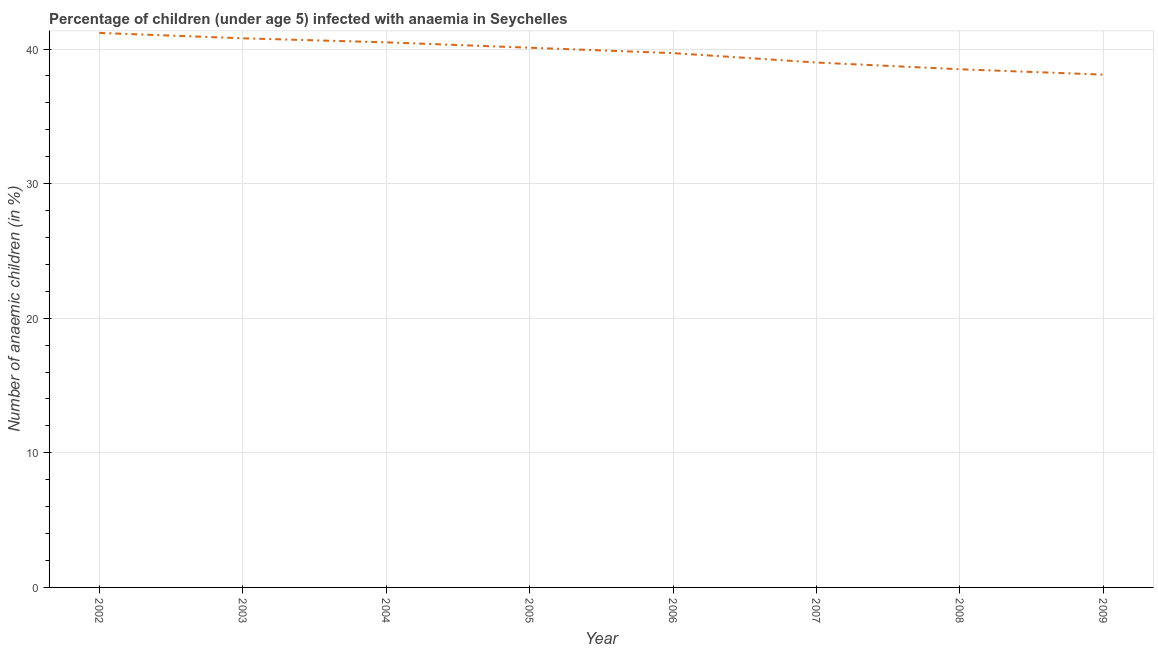What is the number of anaemic children in 2009?
Make the answer very short. 38.1. Across all years, what is the maximum number of anaemic children?
Your answer should be very brief. 41.2. Across all years, what is the minimum number of anaemic children?
Provide a succinct answer. 38.1. In which year was the number of anaemic children maximum?
Give a very brief answer. 2002. What is the sum of the number of anaemic children?
Your answer should be very brief. 317.9. What is the difference between the number of anaemic children in 2002 and 2007?
Keep it short and to the point. 2.2. What is the average number of anaemic children per year?
Your response must be concise. 39.74. What is the median number of anaemic children?
Keep it short and to the point. 39.9. In how many years, is the number of anaemic children greater than 34 %?
Provide a short and direct response. 8. What is the ratio of the number of anaemic children in 2005 to that in 2009?
Your answer should be compact. 1.05. Is the number of anaemic children in 2002 less than that in 2004?
Give a very brief answer. No. Is the difference between the number of anaemic children in 2004 and 2009 greater than the difference between any two years?
Provide a short and direct response. No. What is the difference between the highest and the second highest number of anaemic children?
Provide a short and direct response. 0.4. Is the sum of the number of anaemic children in 2002 and 2004 greater than the maximum number of anaemic children across all years?
Provide a succinct answer. Yes. What is the difference between the highest and the lowest number of anaemic children?
Give a very brief answer. 3.1. What is the difference between two consecutive major ticks on the Y-axis?
Provide a short and direct response. 10. Are the values on the major ticks of Y-axis written in scientific E-notation?
Your answer should be very brief. No. Does the graph contain grids?
Keep it short and to the point. Yes. What is the title of the graph?
Make the answer very short. Percentage of children (under age 5) infected with anaemia in Seychelles. What is the label or title of the X-axis?
Provide a short and direct response. Year. What is the label or title of the Y-axis?
Your response must be concise. Number of anaemic children (in %). What is the Number of anaemic children (in %) in 2002?
Keep it short and to the point. 41.2. What is the Number of anaemic children (in %) of 2003?
Give a very brief answer. 40.8. What is the Number of anaemic children (in %) of 2004?
Offer a very short reply. 40.5. What is the Number of anaemic children (in %) in 2005?
Your answer should be compact. 40.1. What is the Number of anaemic children (in %) in 2006?
Your response must be concise. 39.7. What is the Number of anaemic children (in %) of 2008?
Your answer should be compact. 38.5. What is the Number of anaemic children (in %) of 2009?
Your answer should be compact. 38.1. What is the difference between the Number of anaemic children (in %) in 2002 and 2004?
Offer a very short reply. 0.7. What is the difference between the Number of anaemic children (in %) in 2002 and 2005?
Give a very brief answer. 1.1. What is the difference between the Number of anaemic children (in %) in 2002 and 2007?
Keep it short and to the point. 2.2. What is the difference between the Number of anaemic children (in %) in 2002 and 2008?
Offer a terse response. 2.7. What is the difference between the Number of anaemic children (in %) in 2002 and 2009?
Provide a short and direct response. 3.1. What is the difference between the Number of anaemic children (in %) in 2003 and 2005?
Provide a succinct answer. 0.7. What is the difference between the Number of anaemic children (in %) in 2003 and 2007?
Your answer should be very brief. 1.8. What is the difference between the Number of anaemic children (in %) in 2004 and 2006?
Offer a terse response. 0.8. What is the difference between the Number of anaemic children (in %) in 2004 and 2007?
Offer a very short reply. 1.5. What is the difference between the Number of anaemic children (in %) in 2005 and 2007?
Ensure brevity in your answer.  1.1. What is the difference between the Number of anaemic children (in %) in 2005 and 2008?
Provide a short and direct response. 1.6. What is the difference between the Number of anaemic children (in %) in 2006 and 2009?
Offer a very short reply. 1.6. What is the difference between the Number of anaemic children (in %) in 2008 and 2009?
Make the answer very short. 0.4. What is the ratio of the Number of anaemic children (in %) in 2002 to that in 2003?
Provide a short and direct response. 1.01. What is the ratio of the Number of anaemic children (in %) in 2002 to that in 2006?
Your response must be concise. 1.04. What is the ratio of the Number of anaemic children (in %) in 2002 to that in 2007?
Give a very brief answer. 1.06. What is the ratio of the Number of anaemic children (in %) in 2002 to that in 2008?
Give a very brief answer. 1.07. What is the ratio of the Number of anaemic children (in %) in 2002 to that in 2009?
Keep it short and to the point. 1.08. What is the ratio of the Number of anaemic children (in %) in 2003 to that in 2004?
Provide a short and direct response. 1.01. What is the ratio of the Number of anaemic children (in %) in 2003 to that in 2005?
Keep it short and to the point. 1.02. What is the ratio of the Number of anaemic children (in %) in 2003 to that in 2006?
Make the answer very short. 1.03. What is the ratio of the Number of anaemic children (in %) in 2003 to that in 2007?
Your response must be concise. 1.05. What is the ratio of the Number of anaemic children (in %) in 2003 to that in 2008?
Provide a succinct answer. 1.06. What is the ratio of the Number of anaemic children (in %) in 2003 to that in 2009?
Provide a short and direct response. 1.07. What is the ratio of the Number of anaemic children (in %) in 2004 to that in 2005?
Keep it short and to the point. 1.01. What is the ratio of the Number of anaemic children (in %) in 2004 to that in 2007?
Provide a succinct answer. 1.04. What is the ratio of the Number of anaemic children (in %) in 2004 to that in 2008?
Provide a short and direct response. 1.05. What is the ratio of the Number of anaemic children (in %) in 2004 to that in 2009?
Provide a succinct answer. 1.06. What is the ratio of the Number of anaemic children (in %) in 2005 to that in 2007?
Your answer should be very brief. 1.03. What is the ratio of the Number of anaemic children (in %) in 2005 to that in 2008?
Your response must be concise. 1.04. What is the ratio of the Number of anaemic children (in %) in 2005 to that in 2009?
Your answer should be very brief. 1.05. What is the ratio of the Number of anaemic children (in %) in 2006 to that in 2008?
Provide a short and direct response. 1.03. What is the ratio of the Number of anaemic children (in %) in 2006 to that in 2009?
Give a very brief answer. 1.04. What is the ratio of the Number of anaemic children (in %) in 2008 to that in 2009?
Keep it short and to the point. 1.01. 